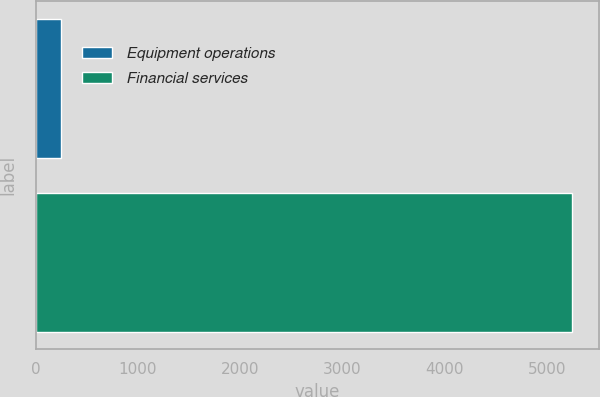<chart> <loc_0><loc_0><loc_500><loc_500><bar_chart><fcel>Equipment operations<fcel>Financial services<nl><fcel>244<fcel>5249<nl></chart> 